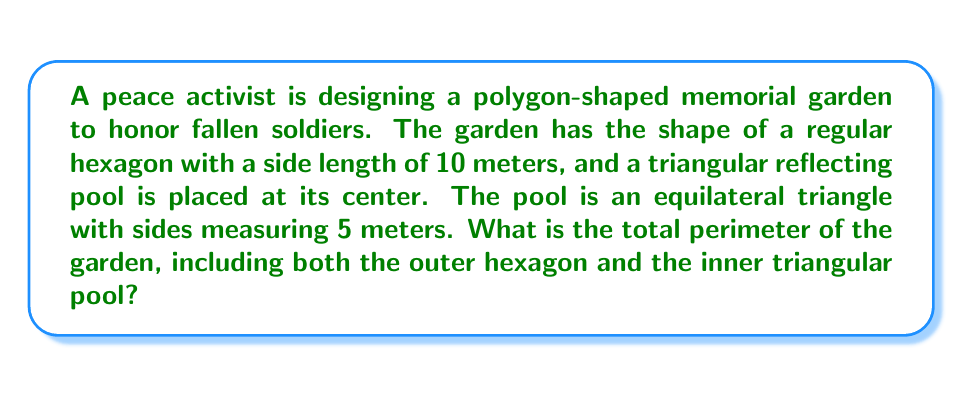Solve this math problem. Let's approach this step-by-step:

1) First, we need to calculate the perimeter of the hexagonal garden:
   - The garden is a regular hexagon with side length 10 meters
   - A hexagon has 6 sides
   - Perimeter of hexagon = $6 \times 10 = 60$ meters

2) Next, we calculate the perimeter of the triangular pool:
   - The pool is an equilateral triangle with side length 5 meters
   - A triangle has 3 sides
   - Perimeter of triangle = $3 \times 5 = 15$ meters

3) The total perimeter is the sum of both perimeters:
   Total perimeter = Perimeter of hexagon + Perimeter of triangle
   $$ \text{Total perimeter} = 60 + 15 = 75 \text{ meters} $$

[asy]
unitsize(10mm);
pair A=(0,0), B=(1,0), C=(1.5,0.866), D=(1,1.732), E=(0,1.732), F=(-0.5,0.866);
pair G=(0.5,0.866), H=(0.75,0.433), I=(0.25,0.433);
draw(A--B--C--D--E--F--cycle);
draw(G--H--I--cycle);
label("10m", (A+B)/2, S);
label("5m", (G+H)/2, SE);
[/asy]
Answer: 75 meters 